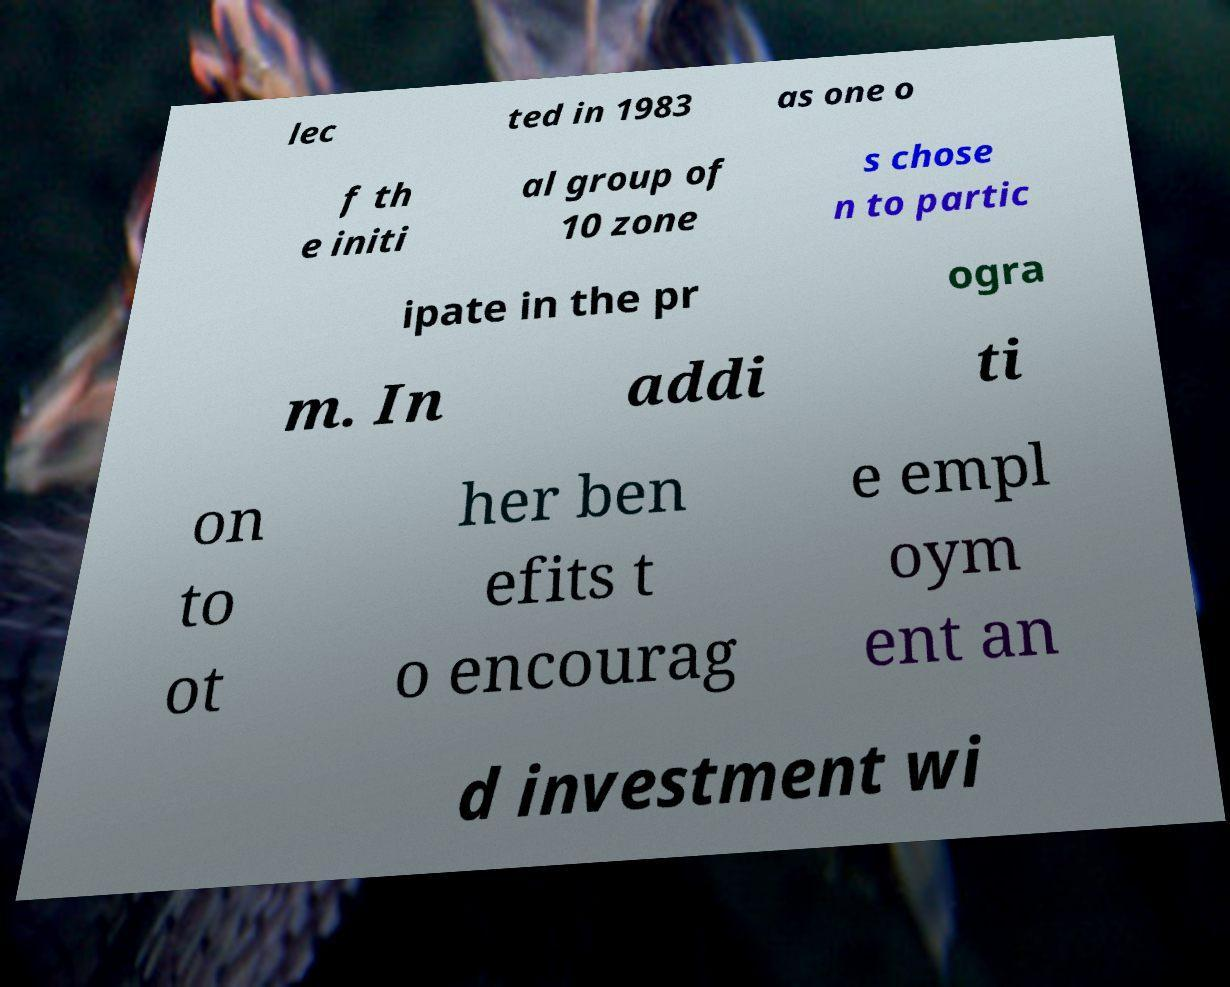There's text embedded in this image that I need extracted. Can you transcribe it verbatim? lec ted in 1983 as one o f th e initi al group of 10 zone s chose n to partic ipate in the pr ogra m. In addi ti on to ot her ben efits t o encourag e empl oym ent an d investment wi 